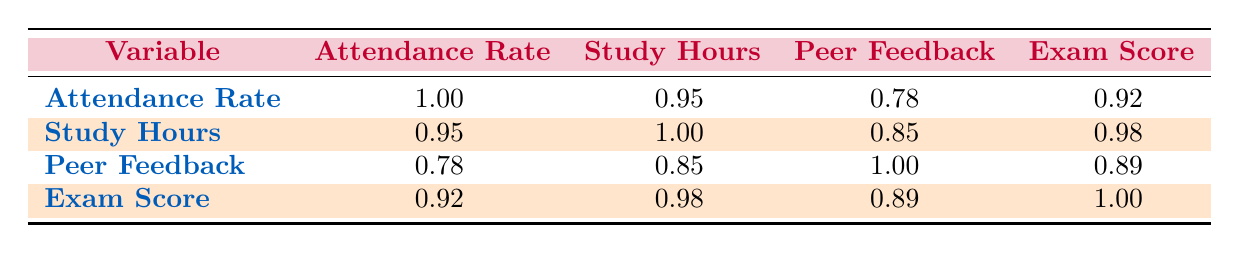What is the highest attendance rate among the students? The highest attendance rate is found by looking for the maximum value in the attendance rates column: 95.
Answer: 95 Is there a correlation between attendance rate and exam scores? Yes, the correlation coefficient between attendance rate and exam scores is 0.92, indicating a strong positive correlation.
Answer: Yes What is the average study hours per week across all students? To find the average, sum the study hours (10 + 12 + 8 + 9 + 15 + 14 = 68) and divide by the number of students (6). Thus, 68/6 = approximately 11.33.
Answer: 11.33 Do students who attend more classes generally receive higher peer feedback scores? Yes, as the correlation between attendance rate and peer feedback is 0.78, suggesting that those who attend more frequently tend to receive better feedback from peers.
Answer: Yes What is the difference between the highest and lowest exam scores? The highest exam score is 90 and the lowest is 65. Therefore, the difference is calculated as 90 - 65 = 25.
Answer: 25 Which variable has the strongest correlation with exam scores? Exam scores have the highest correlation with study hours (0.98), indicating that more study hours are strongly associated with higher exam scores.
Answer: Study hours If a student's attendance rate was to increase by 5%, what would the expected change in exam score be based on the correlation? Given the correlation between attendance rate and exam score is 0.92, a 5% increase in attendance could likely lead to an increase in exam scores; multiplying 0.92 by 5 gives an expected change of approximately 4.6 points in exam score.
Answer: 4.6 Is the peer feedback score highest for the student with the most study hours? No, even though Hassan Boukhris has the most study hours (15), Fatima Ouedraogo has a lower score despite fewer study hours.
Answer: No Which student's feedback score was lower than their study hours per week? Fatima Ouedraogo has a peer feedback score of 3.5 while studying 9 hours per week, indicating her feedback score is lower than her study time.
Answer: Fatima Ouedraogo 